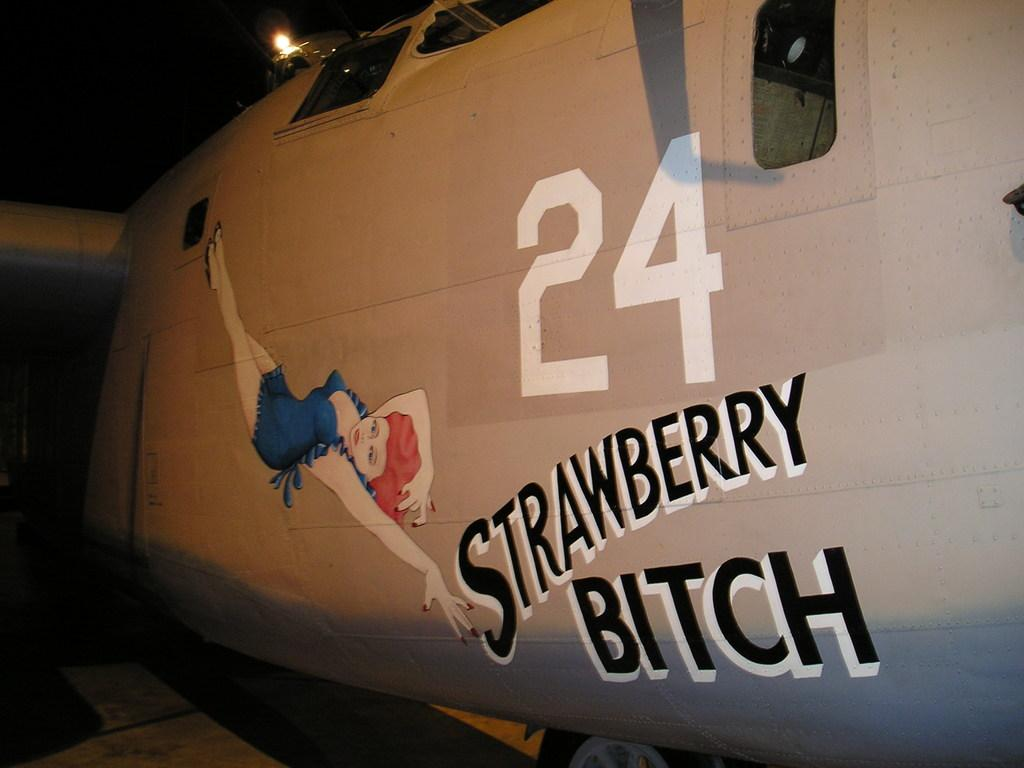Provide a one-sentence caption for the provided image. An airplane has the #24 and the words Strawberry B**ch on the side. 